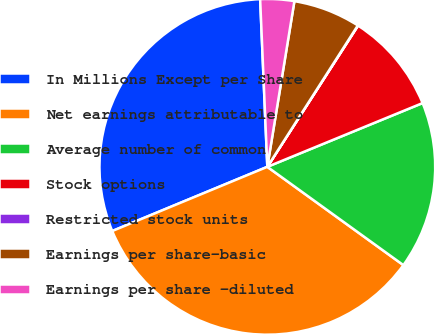Convert chart to OTSL. <chart><loc_0><loc_0><loc_500><loc_500><pie_chart><fcel>In Millions Except per Share<fcel>Net earnings attributable to<fcel>Average number of common<fcel>Stock options<fcel>Restricted stock units<fcel>Earnings per share-basic<fcel>Earnings per share -diluted<nl><fcel>30.57%<fcel>33.8%<fcel>16.16%<fcel>9.71%<fcel>0.03%<fcel>6.48%<fcel>3.26%<nl></chart> 